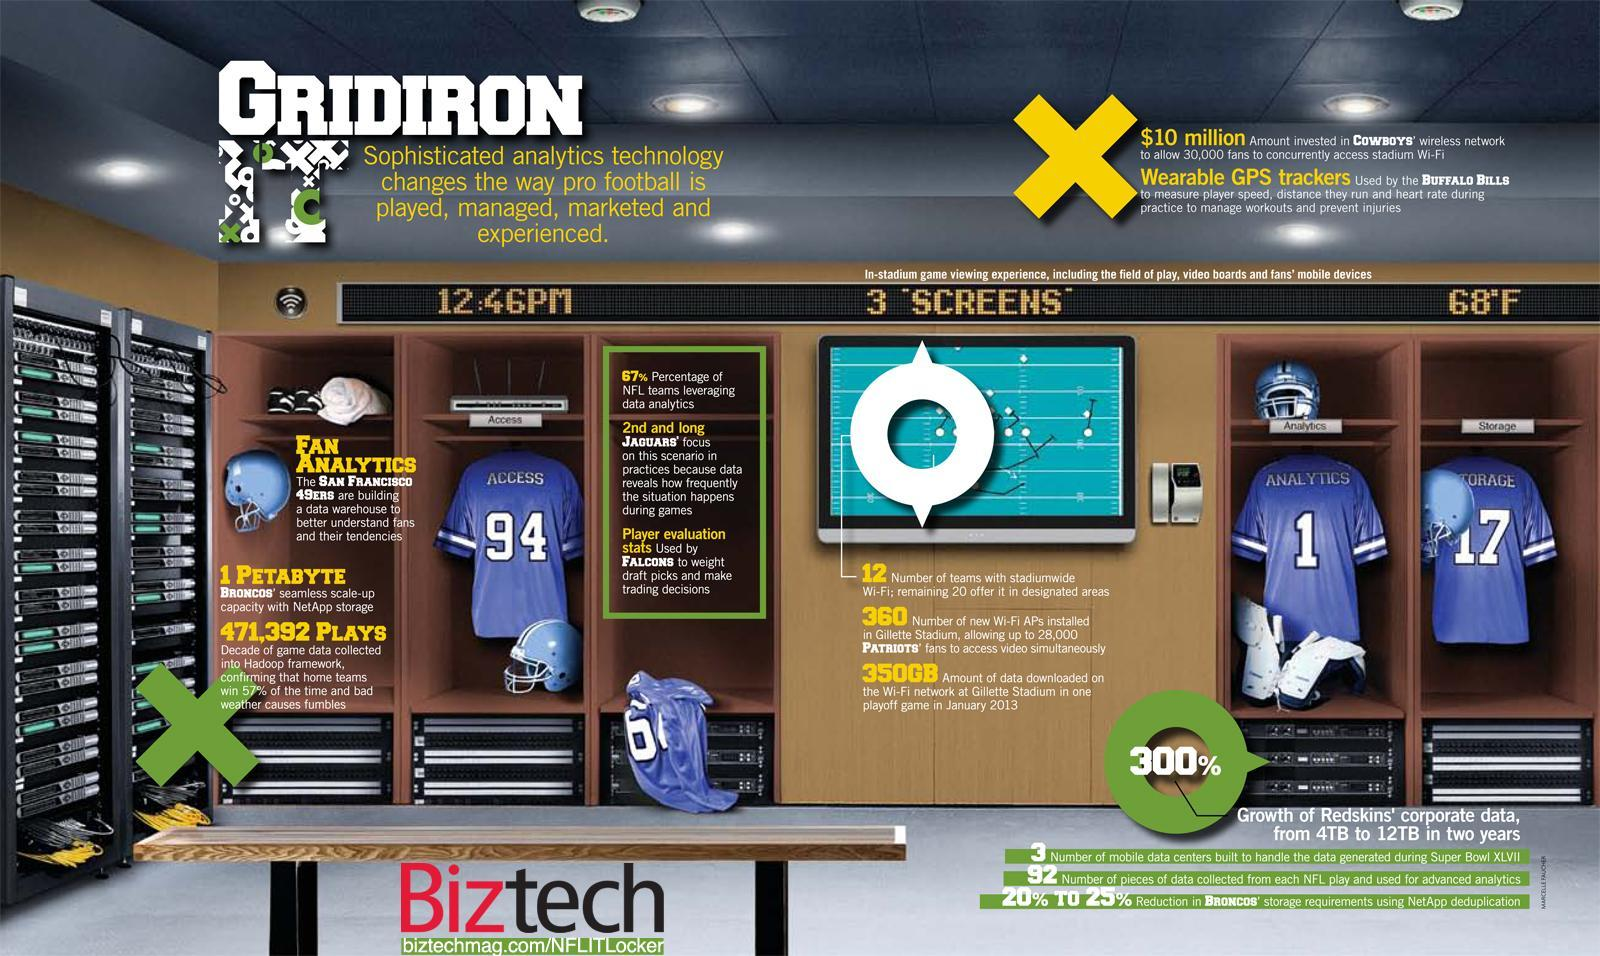Who is building a data warehouse to understand fans and their tendencies?
Answer the question with a short phrase. San Francisco 49ers What is used to pick drafts and make trading decisions? Player evaluation stats 